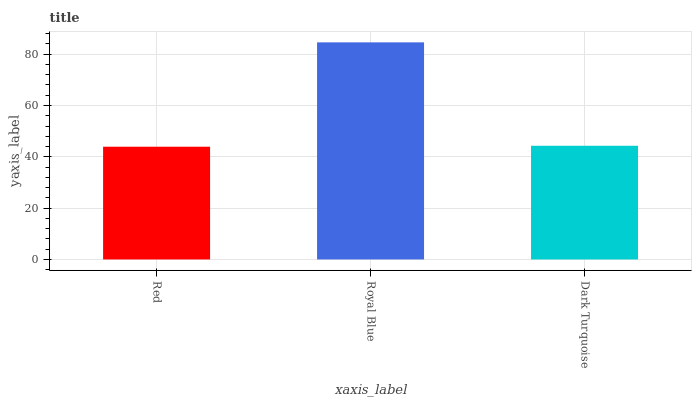Is Dark Turquoise the minimum?
Answer yes or no. No. Is Dark Turquoise the maximum?
Answer yes or no. No. Is Royal Blue greater than Dark Turquoise?
Answer yes or no. Yes. Is Dark Turquoise less than Royal Blue?
Answer yes or no. Yes. Is Dark Turquoise greater than Royal Blue?
Answer yes or no. No. Is Royal Blue less than Dark Turquoise?
Answer yes or no. No. Is Dark Turquoise the high median?
Answer yes or no. Yes. Is Dark Turquoise the low median?
Answer yes or no. Yes. Is Royal Blue the high median?
Answer yes or no. No. Is Royal Blue the low median?
Answer yes or no. No. 